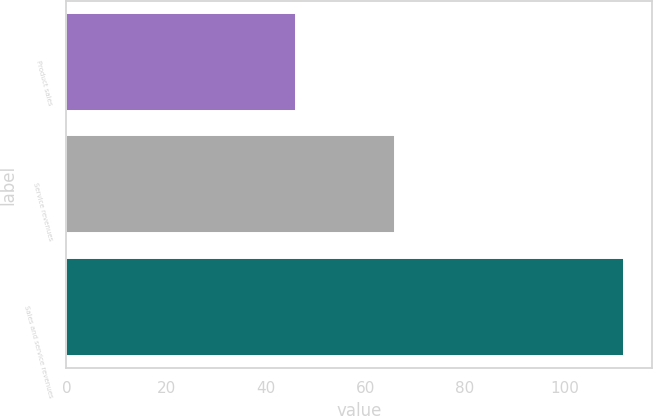<chart> <loc_0><loc_0><loc_500><loc_500><bar_chart><fcel>Product sales<fcel>Service revenues<fcel>Sales and service revenues<nl><fcel>46<fcel>66<fcel>112<nl></chart> 